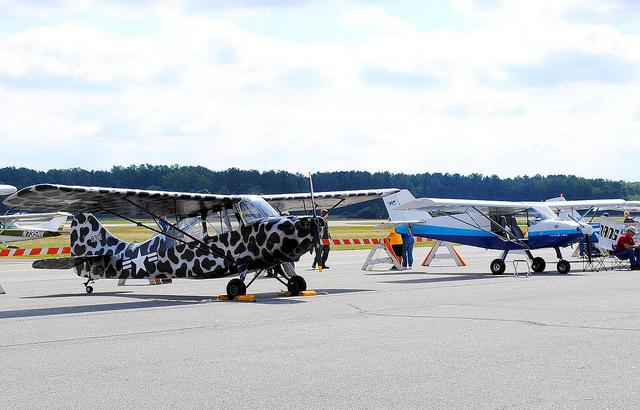What animal mimics the pattern of the plane to the left? cheetah 